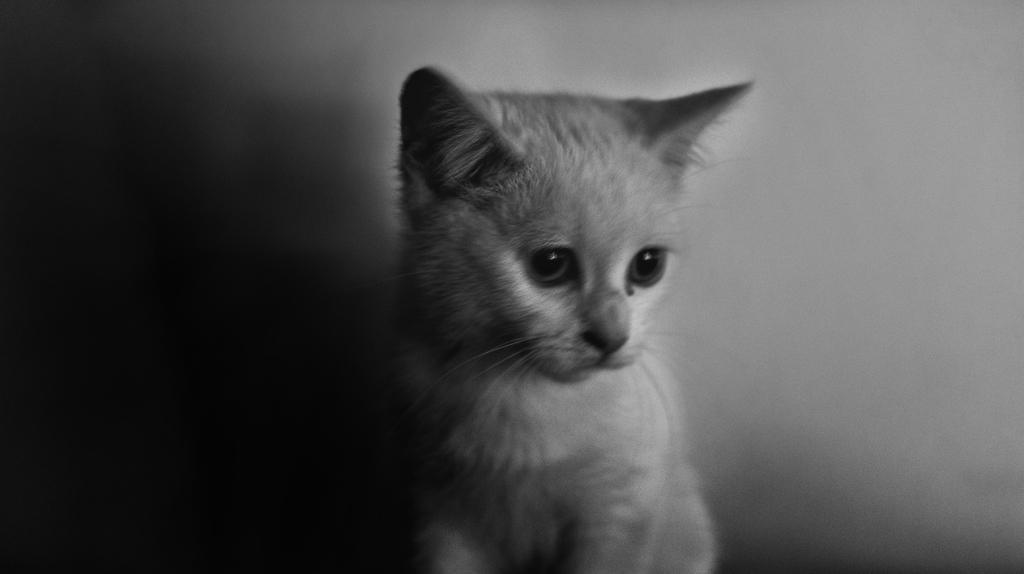Could you give a brief overview of what you see in this image? In this image, we can see a cat. On the left side of the image, we can see a dark view. 